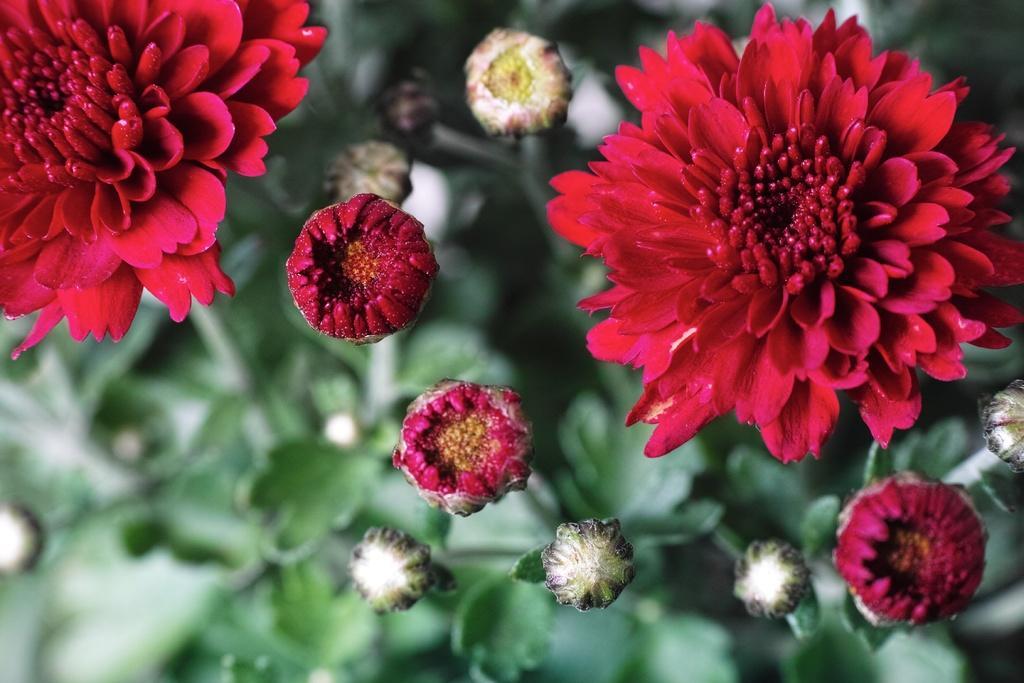Can you describe this image briefly? Here in this picture we can see flowers present on the plants over there. 